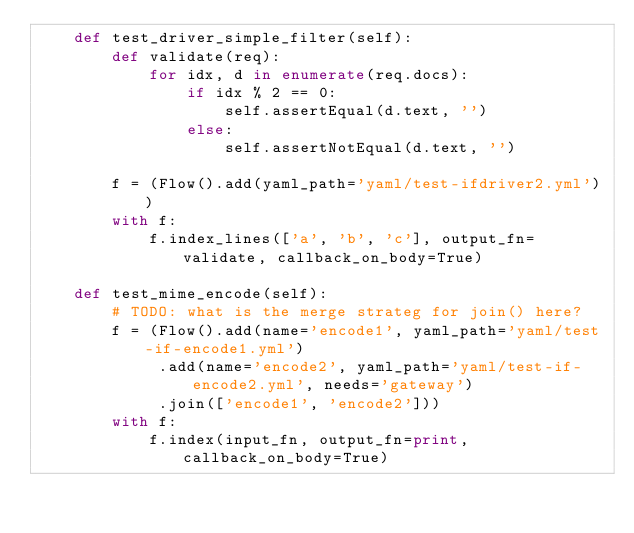<code> <loc_0><loc_0><loc_500><loc_500><_Python_>    def test_driver_simple_filter(self):
        def validate(req):
            for idx, d in enumerate(req.docs):
                if idx % 2 == 0:
                    self.assertEqual(d.text, '')
                else:
                    self.assertNotEqual(d.text, '')

        f = (Flow().add(yaml_path='yaml/test-ifdriver2.yml'))
        with f:
            f.index_lines(['a', 'b', 'c'], output_fn=validate, callback_on_body=True)

    def test_mime_encode(self):
        # TODO: what is the merge strateg for join() here?
        f = (Flow().add(name='encode1', yaml_path='yaml/test-if-encode1.yml')
             .add(name='encode2', yaml_path='yaml/test-if-encode2.yml', needs='gateway')
             .join(['encode1', 'encode2']))
        with f:
            f.index(input_fn, output_fn=print, callback_on_body=True)
</code> 